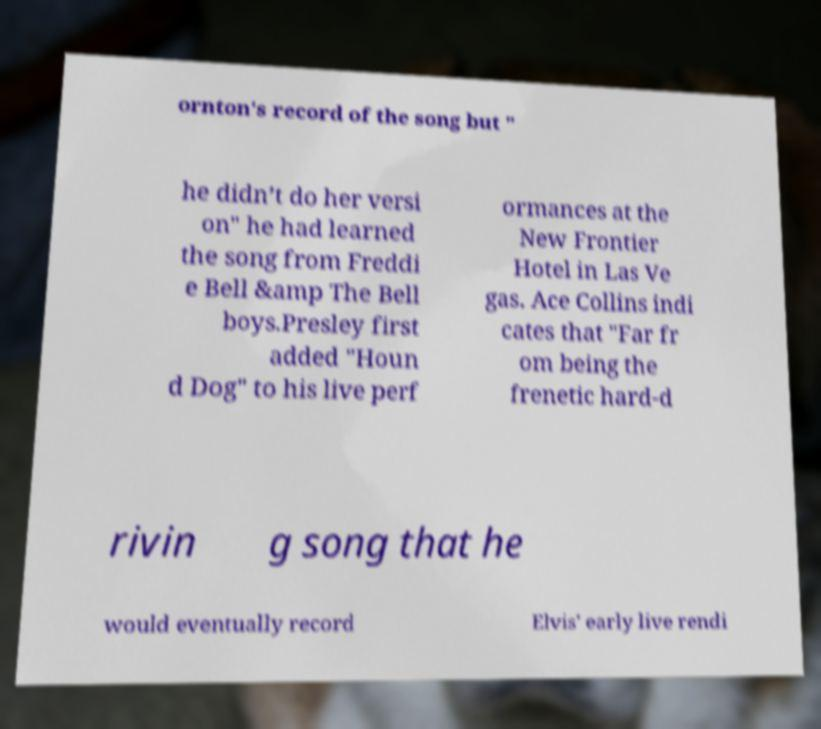I need the written content from this picture converted into text. Can you do that? ornton's record of the song but " he didn’t do her versi on" he had learned the song from Freddi e Bell &amp The Bell boys.Presley first added "Houn d Dog" to his live perf ormances at the New Frontier Hotel in Las Ve gas. Ace Collins indi cates that "Far fr om being the frenetic hard-d rivin g song that he would eventually record Elvis' early live rendi 